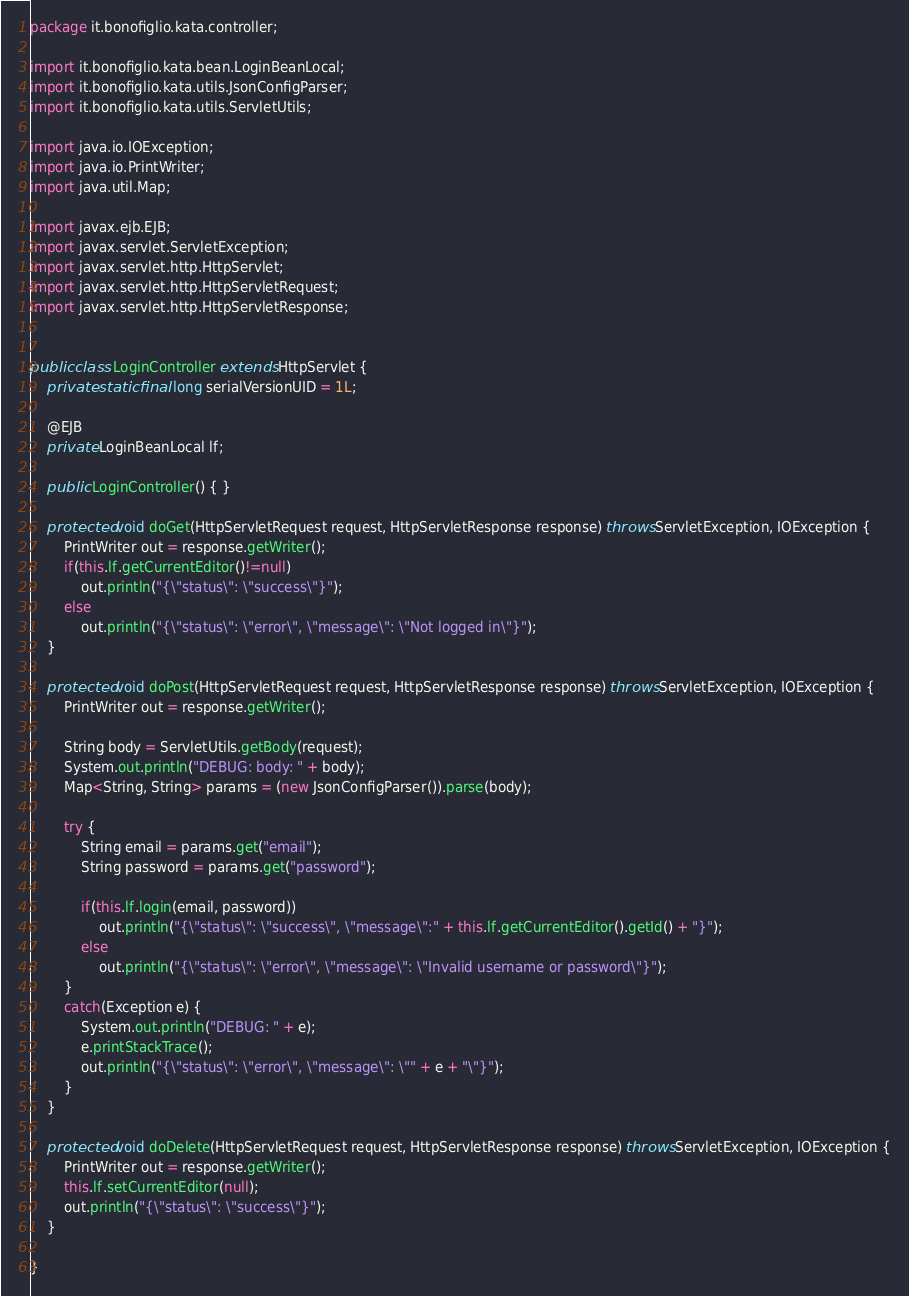<code> <loc_0><loc_0><loc_500><loc_500><_Java_>package it.bonofiglio.kata.controller;

import it.bonofiglio.kata.bean.LoginBeanLocal;
import it.bonofiglio.kata.utils.JsonConfigParser;
import it.bonofiglio.kata.utils.ServletUtils;

import java.io.IOException;
import java.io.PrintWriter;
import java.util.Map;

import javax.ejb.EJB;
import javax.servlet.ServletException;
import javax.servlet.http.HttpServlet;
import javax.servlet.http.HttpServletRequest;
import javax.servlet.http.HttpServletResponse;


public class LoginController extends HttpServlet {
	private static final long serialVersionUID = 1L;
	
	@EJB
	private LoginBeanLocal lf;

    public LoginController() { }

	protected void doGet(HttpServletRequest request, HttpServletResponse response) throws ServletException, IOException {
		PrintWriter out = response.getWriter();
		if(this.lf.getCurrentEditor()!=null) 
			out.println("{\"status\": \"success\"}");
		else 
			out.println("{\"status\": \"error\", \"message\": \"Not logged in\"}");
	}

	protected void doPost(HttpServletRequest request, HttpServletResponse response) throws ServletException, IOException {
		PrintWriter out = response.getWriter();
		
		String body = ServletUtils.getBody(request);
		System.out.println("DEBUG: body: " + body);
		Map<String, String> params = (new JsonConfigParser()).parse(body);
		
		try {
			String email = params.get("email");
			String password = params.get("password");
			
			if(this.lf.login(email, password))
				out.println("{\"status\": \"success\", \"message\":" + this.lf.getCurrentEditor().getId() + "}");
			else 
				out.println("{\"status\": \"error\", \"message\": \"Invalid username or password\"}");
		}
		catch(Exception e) {
			System.out.println("DEBUG: " + e);
			e.printStackTrace();
			out.println("{\"status\": \"error\", \"message\": \"" + e + "\"}");
		}
	}

	protected void doDelete(HttpServletRequest request, HttpServletResponse response) throws ServletException, IOException {
		PrintWriter out = response.getWriter();
		this.lf.setCurrentEditor(null);
		out.println("{\"status\": \"success\"}");
	}

}
</code> 